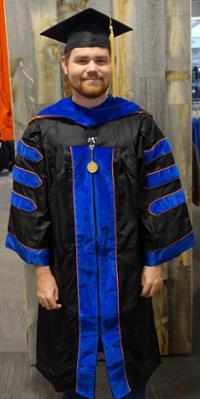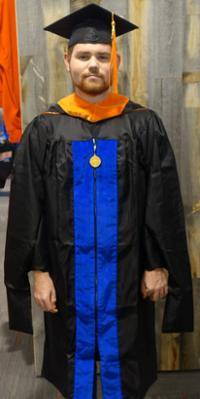The first image is the image on the left, the second image is the image on the right. Evaluate the accuracy of this statement regarding the images: "The right image contains a mannequin wearing a graduation gown.". Is it true? Answer yes or no. No. The first image is the image on the left, the second image is the image on the right. Assess this claim about the two images: "At least one image shows a mannequin modeling a graduation robe with three stripes on each sleeve.". Correct or not? Answer yes or no. No. 